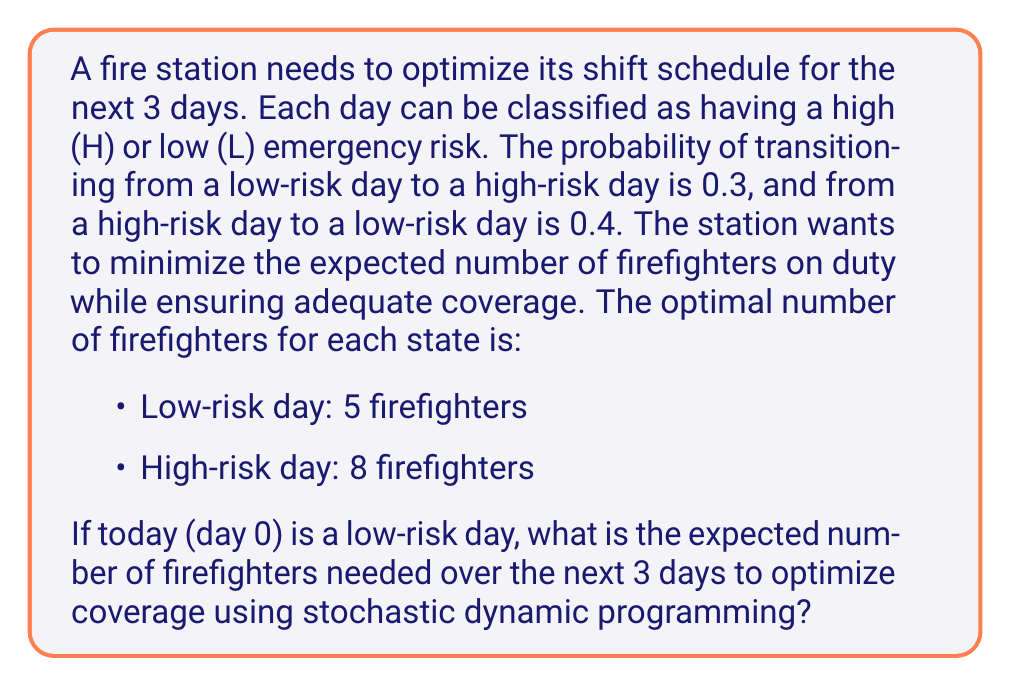Help me with this question. Let's solve this problem using stochastic dynamic programming:

1) First, let's define our state transition probabilities:
   $P(L \to H) = 0.3$, $P(L \to L) = 0.7$
   $P(H \to L) = 0.4$, $P(H \to H) = 0.6$

2) Now, let's work backwards from day 3 to day 1:

   Day 3:
   $V_3(L) = 5$
   $V_3(H) = 8$

   Day 2:
   $V_2(L) = 5 + 0.7V_3(L) + 0.3V_3(H) = 5 + 0.7(5) + 0.3(8) = 8.9$
   $V_2(H) = 8 + 0.4V_3(L) + 0.6V_3(H) = 8 + 0.4(5) + 0.6(8) = 12.8$

   Day 1:
   $V_1(L) = 5 + 0.7V_2(L) + 0.3V_2(H) = 5 + 0.7(8.9) + 0.3(12.8) = 12.47$
   $V_1(H) = 8 + 0.4V_2(L) + 0.6V_2(H) = 8 + 0.4(8.9) + 0.6(12.8) = 15.92$

3) Given that day 0 is a low-risk day, we can calculate the expected number of firefighters for day 1:

   $E[\text{firefighters on day 1}] = 5 + 0.7V_1(L) + 0.3V_1(H) = 5 + 0.7(12.47) + 0.3(15.92) = 18.50$

4) The total expected number of firefighters over the 3 days is the sum of:
   - The known number for day 1 (5, since day 0 is low-risk)
   - The expected number for day 2 (calculated in step 3)
   - The expected numbers for days 2 and 3 (which are included in the calculation from step 3)

   Total = $5 + 18.50 = 23.50$
Answer: 23.50 firefighters 